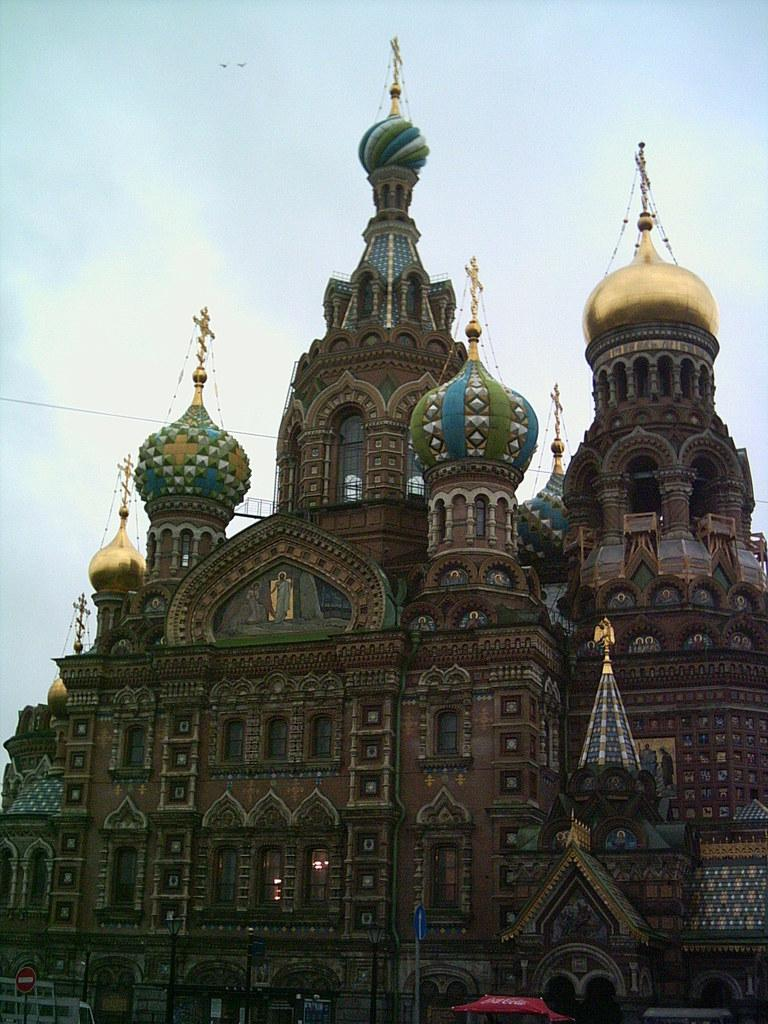What type of structure is the main subject of the image? There is a castle in the image. What can be seen in front of the castle? There are sign boards and tents in front of the castle. What type of glove is being sold at the castle in the image? There is no glove being sold or depicted in the image; it features a castle with sign boards and tents in front of it. 